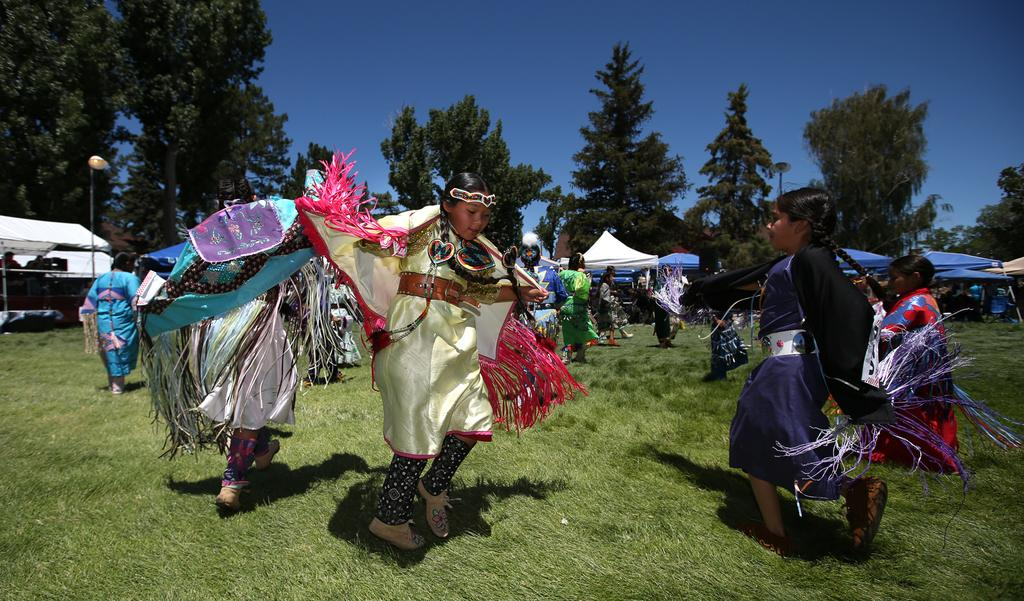What are the people in the image doing? The people in the image are dancing. Where are the people dancing? The people are dancing on the grass. What can be seen in the background of the image? In the background of the image, there are tents, lights, trees, and the sky. What type of food is being served on the arm of the person in the image? There is no food or person with an arm visible in the image. 